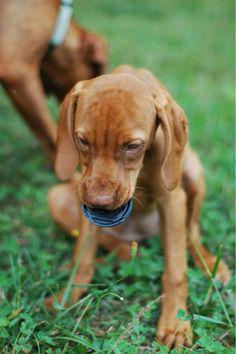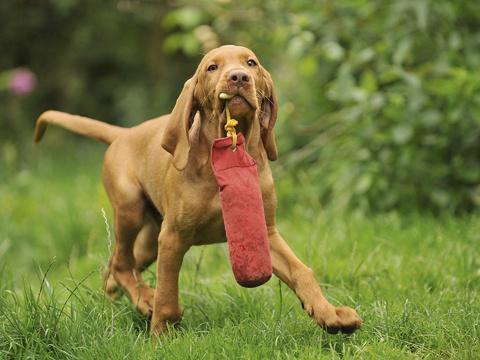The first image is the image on the left, the second image is the image on the right. Assess this claim about the two images: "There are two adult dogs". Correct or not? Answer yes or no. No. The first image is the image on the left, the second image is the image on the right. For the images shown, is this caption "At least one of the dogs is carrying something in its mouth." true? Answer yes or no. Yes. 